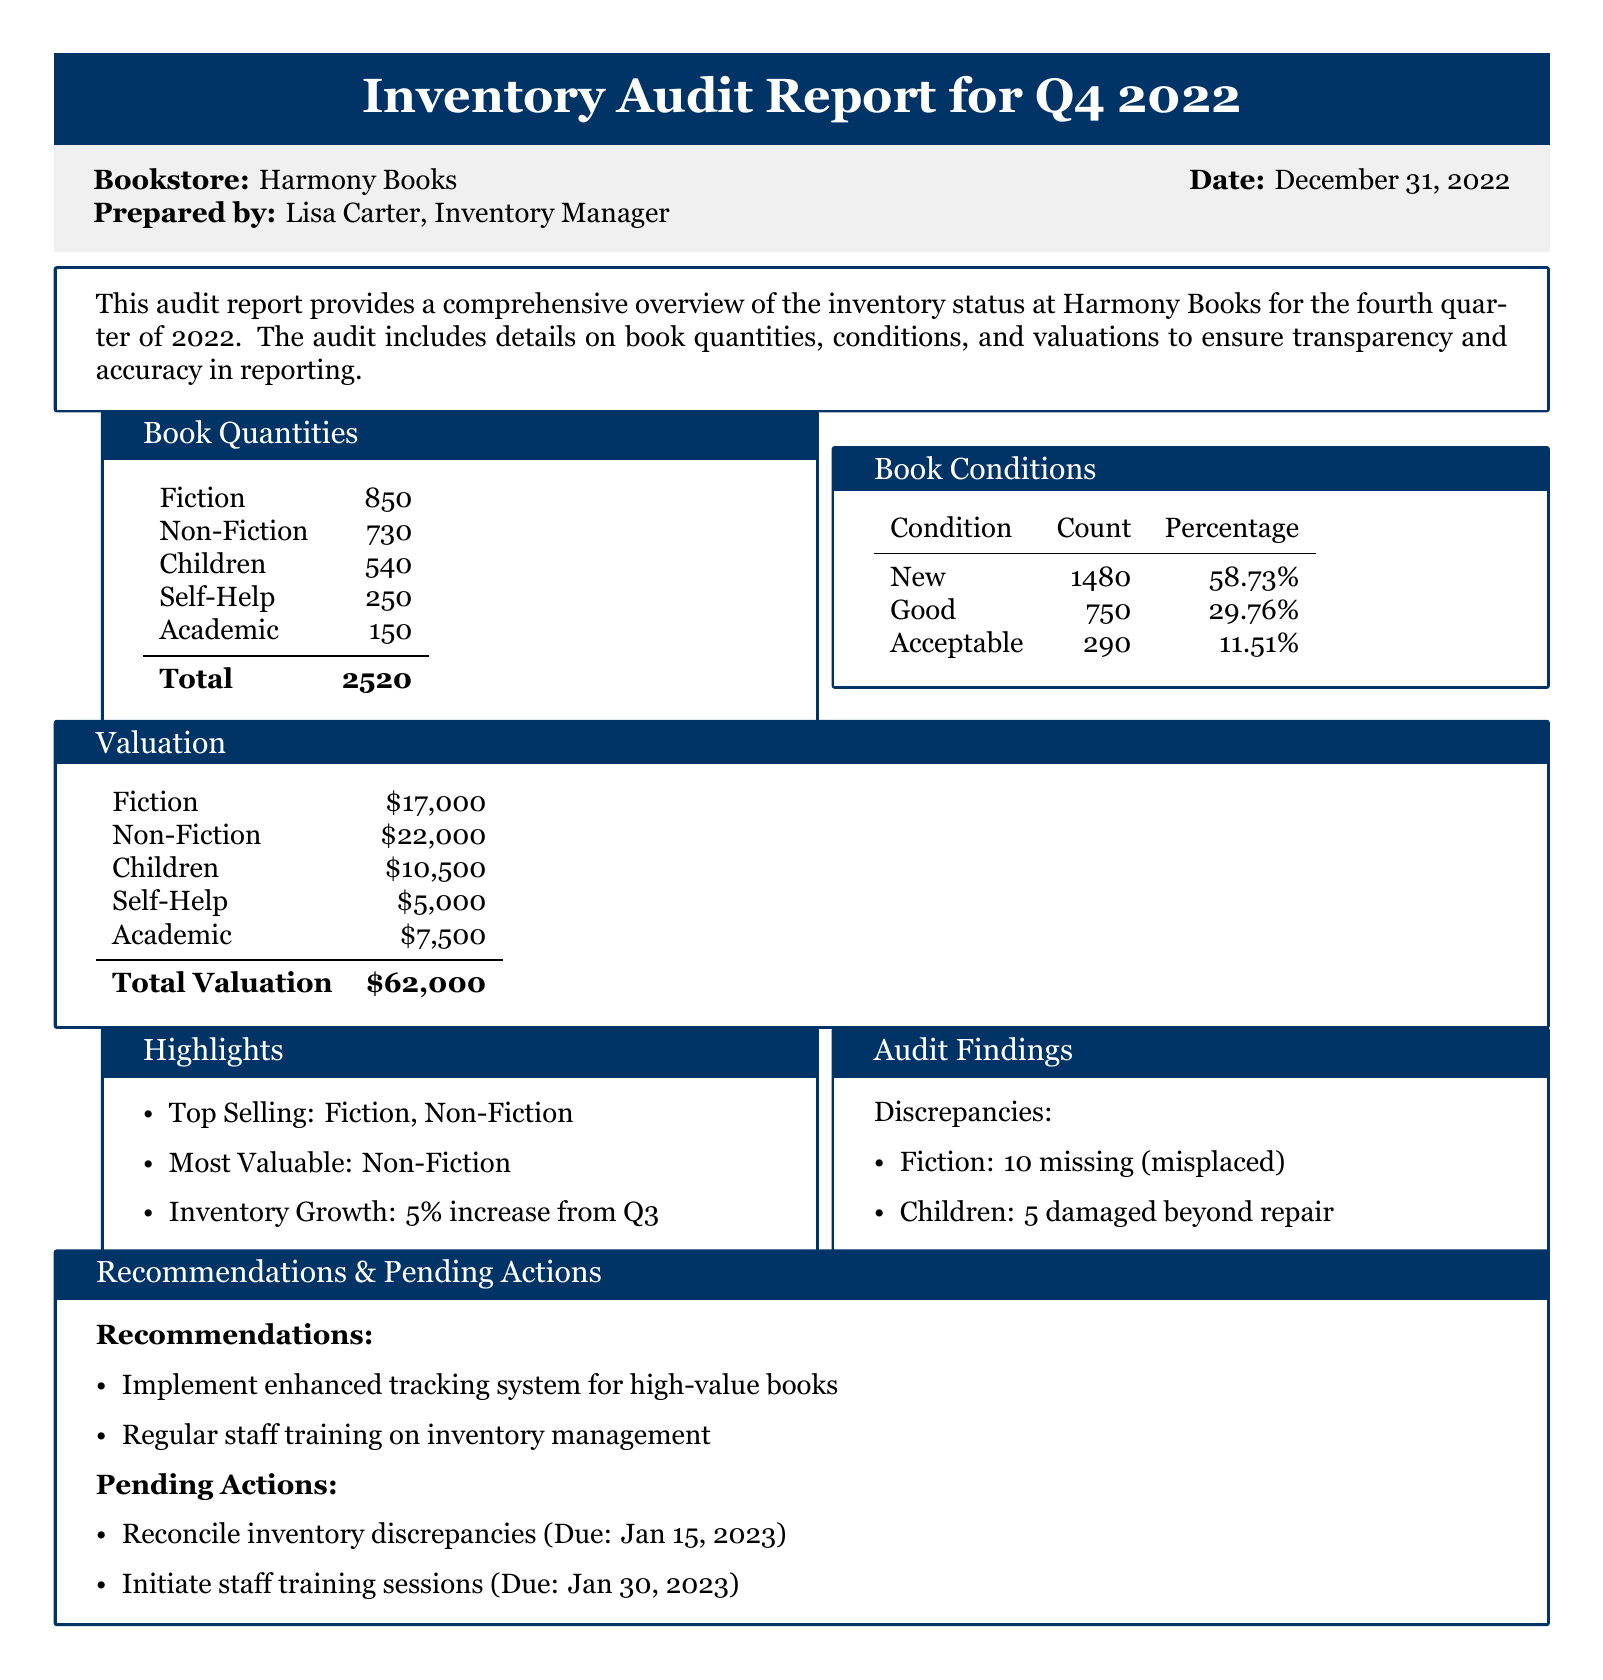What is the total quantity of books? The total quantity is calculated by adding up all book categories listed in the document, resulting in 850 + 730 + 540 + 250 + 150 = 2520.
Answer: 2520 Which book condition has the highest count? This question refers to the table listing book conditions and counts, where 'New' has the highest count of 1480.
Answer: New What is the total valuation of Fiction books? According to the valuation section, Fiction books are valued at $17,000.
Answer: $17,000 How many damaged books were reported in the audit findings? The audit findings indicate that there were 5 damaged books beyond repair in the Children category.
Answer: 5 What percentage of the inventory is classified as 'Good' condition? The document specifies that 'Good' condition books account for 29.76% of the total inventory.
Answer: 29.76% What is the due date for reconciling inventory discrepancies? The document states that reconciliation of inventory discrepancies is due on January 15, 2023.
Answer: January 15, 2023 Which category of books is the most valuable? The summary highlights that the most valuable category is Non-Fiction with a valuation of $22,000.
Answer: Non-Fiction What is the percentage increase in inventory from Q3 to Q4? The highlighted section indicates a 5% increase in inventory from Q3.
Answer: 5% 